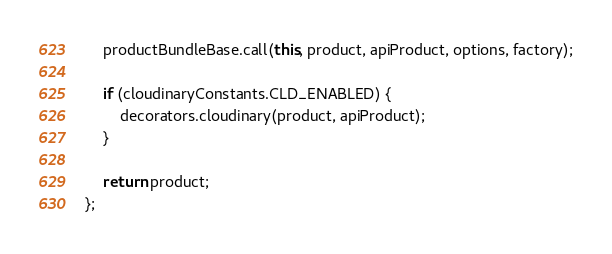<code> <loc_0><loc_0><loc_500><loc_500><_JavaScript_>    productBundleBase.call(this, product, apiProduct, options, factory);

    if (cloudinaryConstants.CLD_ENABLED) {
        decorators.cloudinary(product, apiProduct);
    }

    return product;
};
</code> 